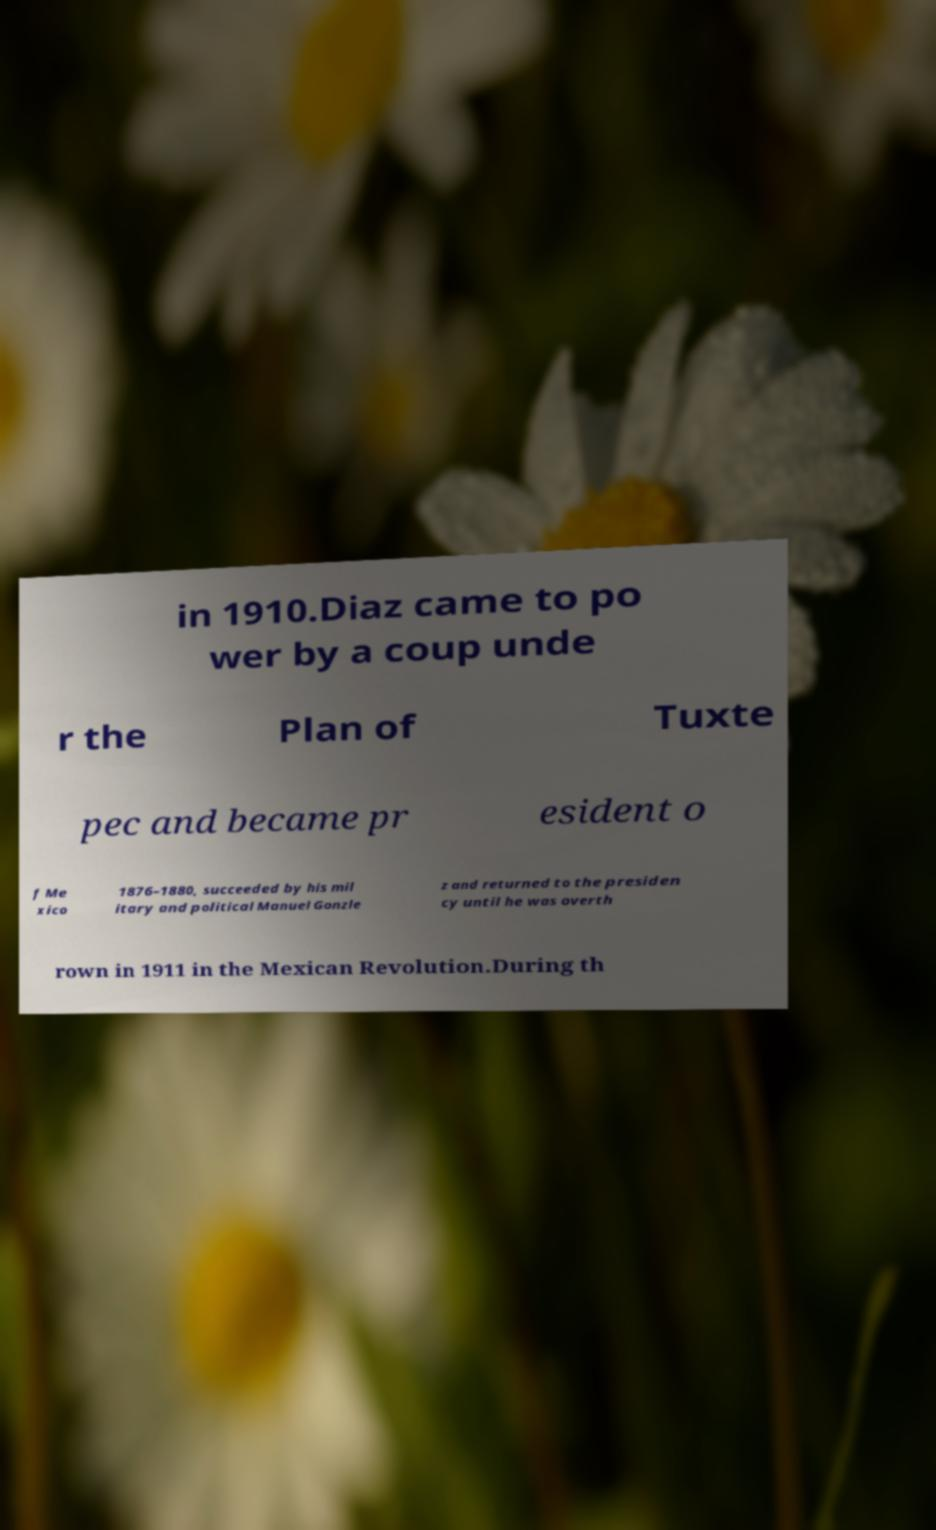There's text embedded in this image that I need extracted. Can you transcribe it verbatim? in 1910.Diaz came to po wer by a coup unde r the Plan of Tuxte pec and became pr esident o f Me xico 1876–1880, succeeded by his mil itary and political Manuel Gonzle z and returned to the presiden cy until he was overth rown in 1911 in the Mexican Revolution.During th 